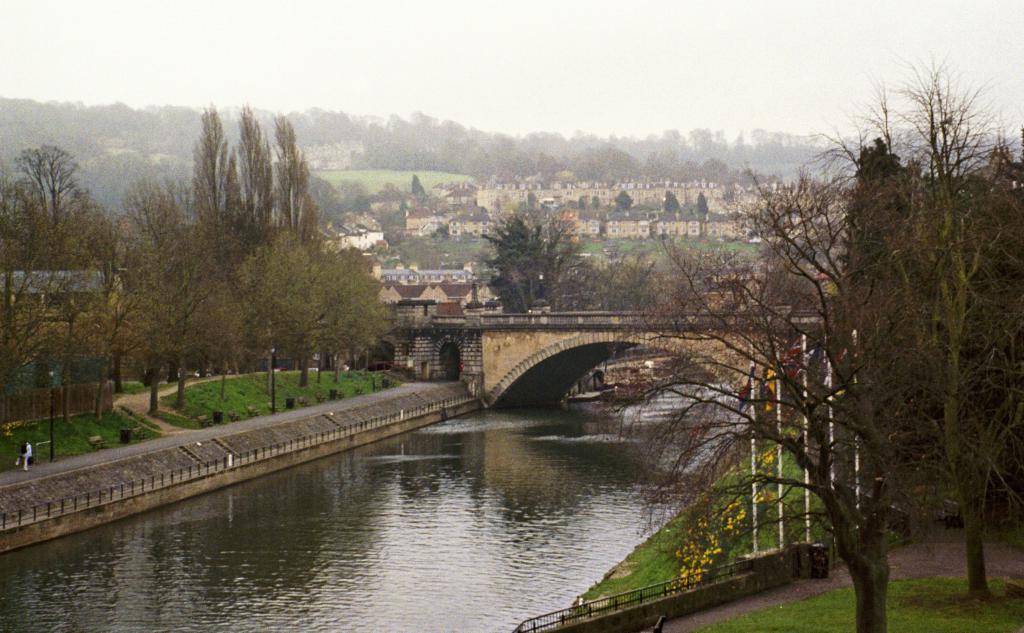Describe this image in one or two sentences. In this picture I can see there is a river and there is a bridge, there is grass, plants with flowers and there are a few poles with flags. In the backdrop, there are few buildings, the sky is clear and foggy. 